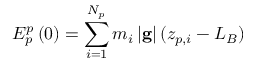<formula> <loc_0><loc_0><loc_500><loc_500>E _ { p } ^ { p } \left ( 0 \right ) = \sum _ { i = 1 } ^ { N _ { p } } m _ { i } \left | g \right | ( z _ { p , i } - L _ { B } )</formula> 